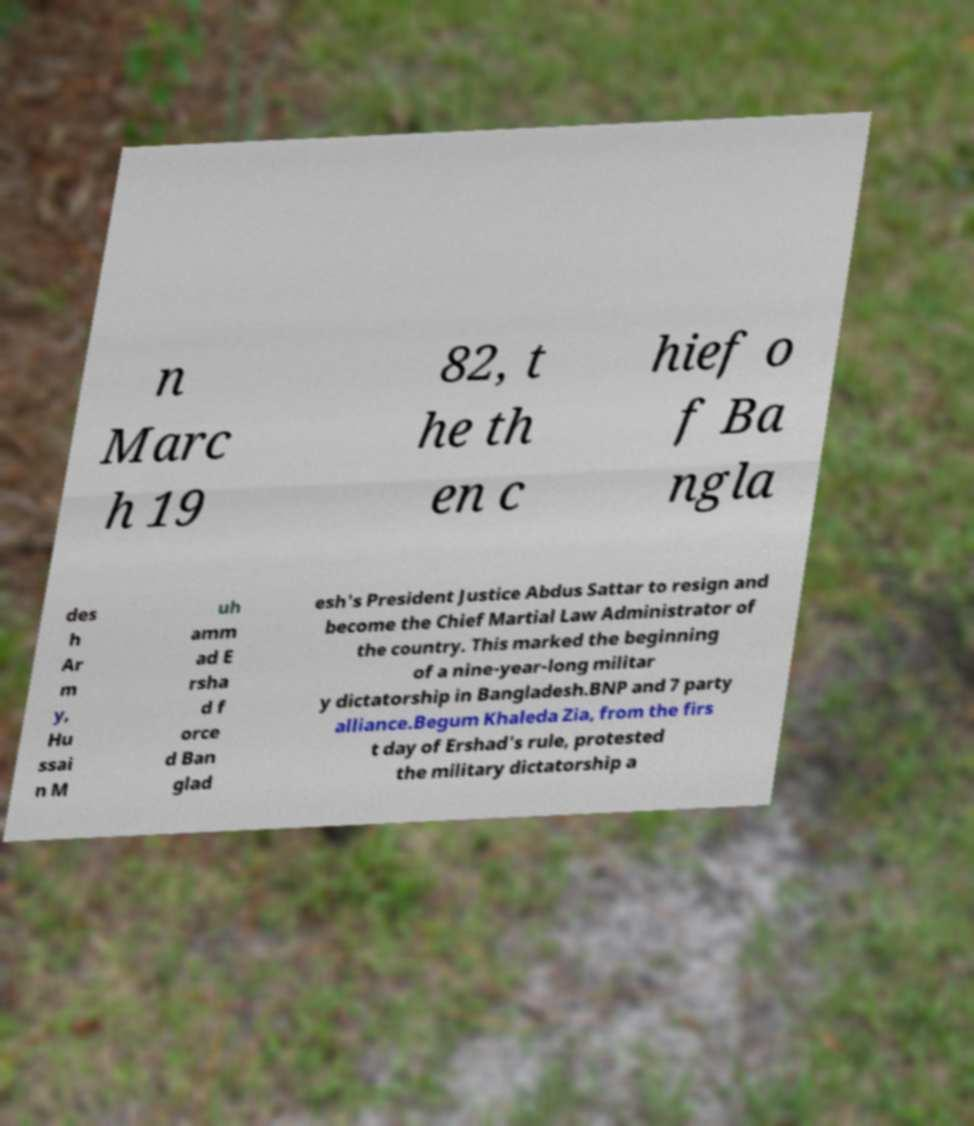Please read and relay the text visible in this image. What does it say? n Marc h 19 82, t he th en c hief o f Ba ngla des h Ar m y, Hu ssai n M uh amm ad E rsha d f orce d Ban glad esh's President Justice Abdus Sattar to resign and become the Chief Martial Law Administrator of the country. This marked the beginning of a nine-year-long militar y dictatorship in Bangladesh.BNP and 7 party alliance.Begum Khaleda Zia, from the firs t day of Ershad's rule, protested the military dictatorship a 